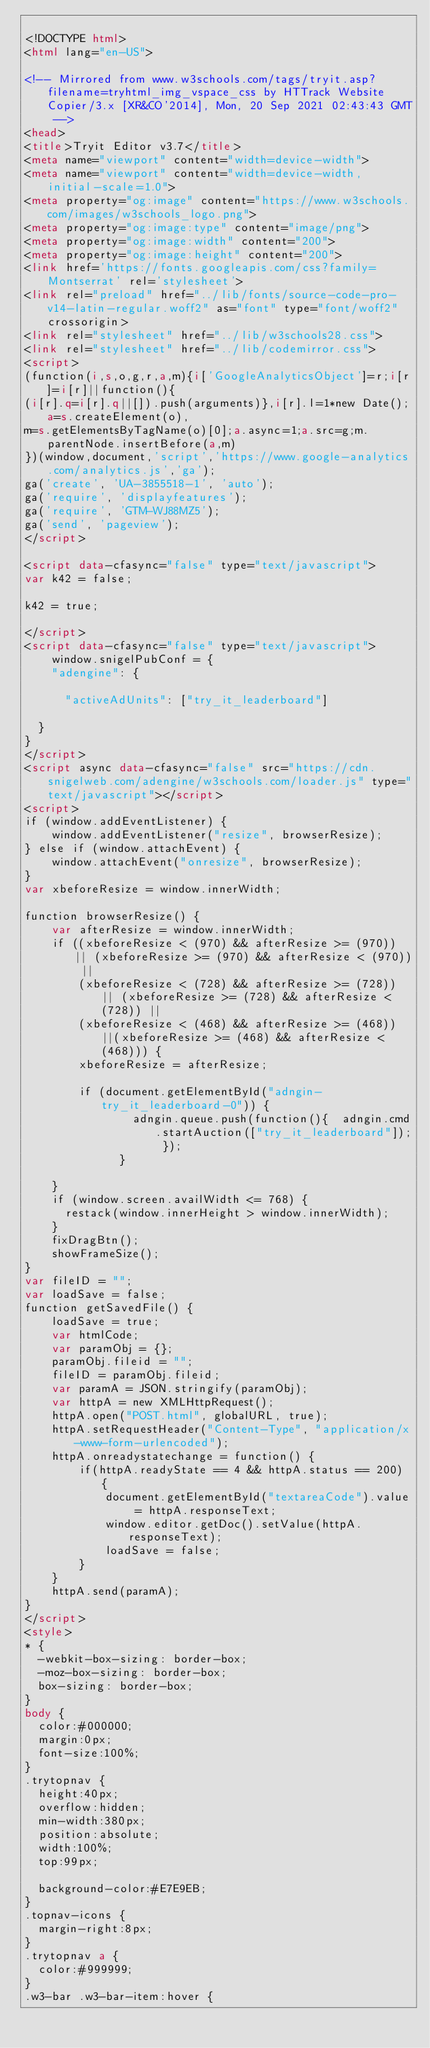<code> <loc_0><loc_0><loc_500><loc_500><_HTML_>
<!DOCTYPE html>
<html lang="en-US">

<!-- Mirrored from www.w3schools.com/tags/tryit.asp?filename=tryhtml_img_vspace_css by HTTrack Website Copier/3.x [XR&CO'2014], Mon, 20 Sep 2021 02:43:43 GMT -->
<head>
<title>Tryit Editor v3.7</title>
<meta name="viewport" content="width=device-width">
<meta name="viewport" content="width=device-width, initial-scale=1.0">
<meta property="og:image" content="https://www.w3schools.com/images/w3schools_logo.png">
<meta property="og:image:type" content="image/png">
<meta property="og:image:width" content="200">
<meta property="og:image:height" content="200">
<link href='https://fonts.googleapis.com/css?family=Montserrat' rel='stylesheet'>
<link rel="preload" href="../lib/fonts/source-code-pro-v14-latin-regular.woff2" as="font" type="font/woff2" crossorigin>
<link rel="stylesheet" href="../lib/w3schools28.css">
<link rel="stylesheet" href="../lib/codemirror.css">
<script>
(function(i,s,o,g,r,a,m){i['GoogleAnalyticsObject']=r;i[r]=i[r]||function(){
(i[r].q=i[r].q||[]).push(arguments)},i[r].l=1*new Date();a=s.createElement(o),
m=s.getElementsByTagName(o)[0];a.async=1;a.src=g;m.parentNode.insertBefore(a,m)
})(window,document,'script','https://www.google-analytics.com/analytics.js','ga');
ga('create', 'UA-3855518-1', 'auto');
ga('require', 'displayfeatures');
ga('require', 'GTM-WJ88MZ5');
ga('send', 'pageview');
</script>

<script data-cfasync="false" type="text/javascript">
var k42 = false;

k42 = true;

</script>
<script data-cfasync="false" type="text/javascript">
    window.snigelPubConf = {
    "adengine": {

      "activeAdUnits": ["try_it_leaderboard"]

  }
}
</script>
<script async data-cfasync="false" src="https://cdn.snigelweb.com/adengine/w3schools.com/loader.js" type="text/javascript"></script>
<script>
if (window.addEventListener) {              
    window.addEventListener("resize", browserResize);
} else if (window.attachEvent) {                 
    window.attachEvent("onresize", browserResize);
}
var xbeforeResize = window.innerWidth;

function browserResize() {
    var afterResize = window.innerWidth;
    if ((xbeforeResize < (970) && afterResize >= (970)) || (xbeforeResize >= (970) && afterResize < (970)) ||
        (xbeforeResize < (728) && afterResize >= (728)) || (xbeforeResize >= (728) && afterResize < (728)) ||
        (xbeforeResize < (468) && afterResize >= (468)) ||(xbeforeResize >= (468) && afterResize < (468))) {
        xbeforeResize = afterResize;
        
        if (document.getElementById("adngin-try_it_leaderboard-0")) {
                adngin.queue.push(function(){  adngin.cmd.startAuction(["try_it_leaderboard"]); });
              }
         
    }
    if (window.screen.availWidth <= 768) {
      restack(window.innerHeight > window.innerWidth);
    }
    fixDragBtn();
    showFrameSize();    
}
var fileID = "";
var loadSave = false;
function getSavedFile() {
    loadSave = true;
    var htmlCode;
    var paramObj = {};
    paramObj.fileid = "";
    fileID = paramObj.fileid;
    var paramA = JSON.stringify(paramObj);
    var httpA = new XMLHttpRequest();
    httpA.open("POST.html", globalURL, true);
    httpA.setRequestHeader("Content-Type", "application/x-www-form-urlencoded");
    httpA.onreadystatechange = function() {
        if(httpA.readyState == 4 && httpA.status == 200) {
            document.getElementById("textareaCode").value = httpA.responseText;
            window.editor.getDoc().setValue(httpA.responseText);
            loadSave = false;
        }
    }
    httpA.send(paramA);   
}
</script>
<style>
* {
  -webkit-box-sizing: border-box;
  -moz-box-sizing: border-box;
  box-sizing: border-box;
}
body {
  color:#000000;
  margin:0px;
  font-size:100%;
}
.trytopnav {
  height:40px;
  overflow:hidden;
  min-width:380px;
  position:absolute;
  width:100%;
  top:99px;

  background-color:#E7E9EB;
}
.topnav-icons {
  margin-right:8px;
}
.trytopnav a {
  color:#999999;
}
.w3-bar .w3-bar-item:hover {</code> 